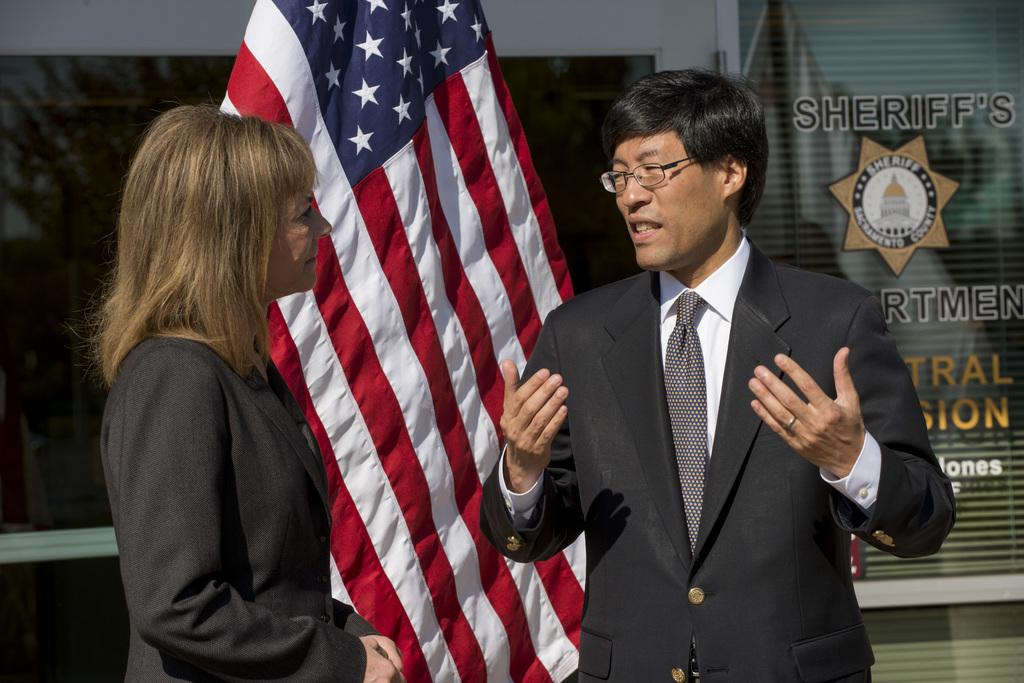Who are the two individuals in the image? There is a person and a woman in the image. What are they doing in the image? Both the person and the woman are standing before a flag. Can you describe the attire of the person in the image? The person is wearing a suit, tie, and spectacles. What is the woman wearing in the image? The woman is wearing a suit. What is the background of the image? There is a glass wall behind the flag. What type of soup is being served in the image? There is no soup present in the image. How many items can be sorted in the image? The image does not involve sorting any items. 